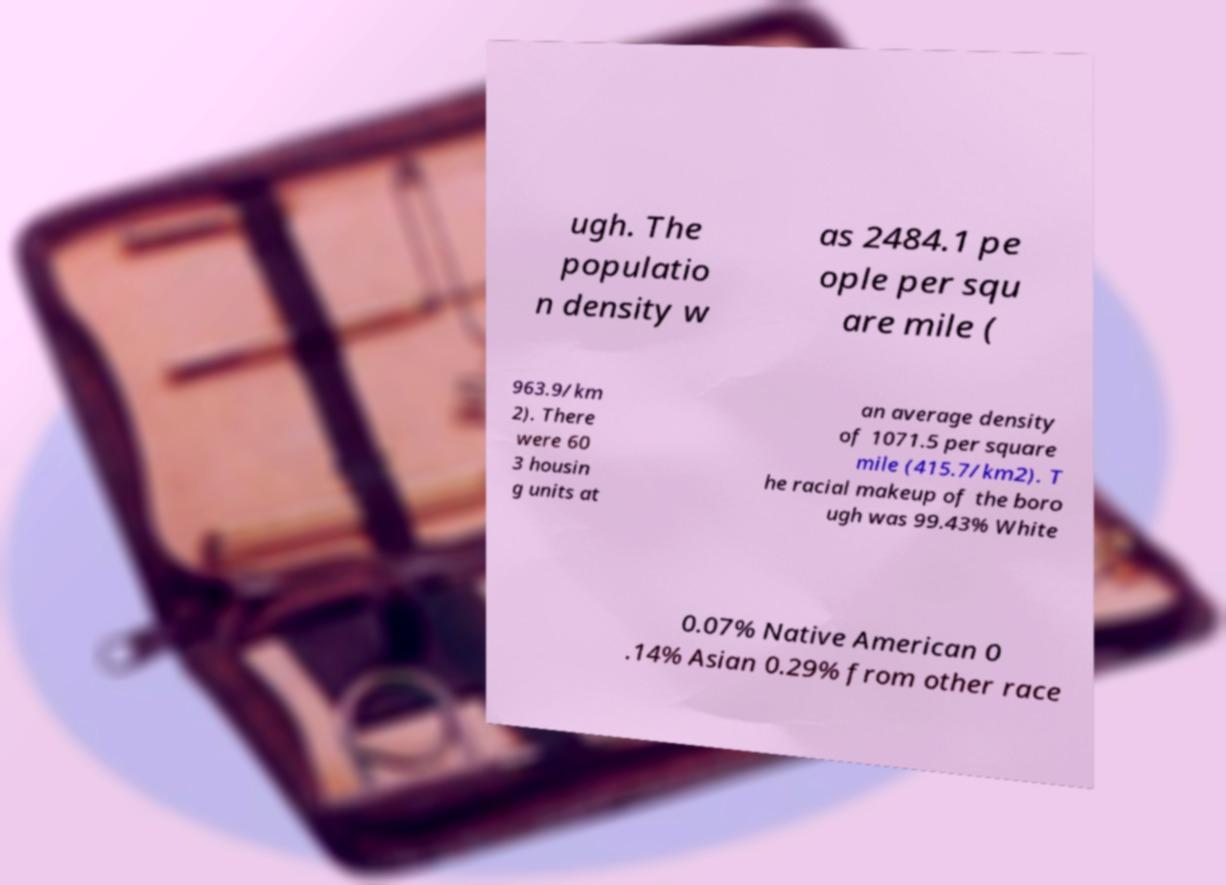What messages or text are displayed in this image? I need them in a readable, typed format. ugh. The populatio n density w as 2484.1 pe ople per squ are mile ( 963.9/km 2). There were 60 3 housin g units at an average density of 1071.5 per square mile (415.7/km2). T he racial makeup of the boro ugh was 99.43% White 0.07% Native American 0 .14% Asian 0.29% from other race 